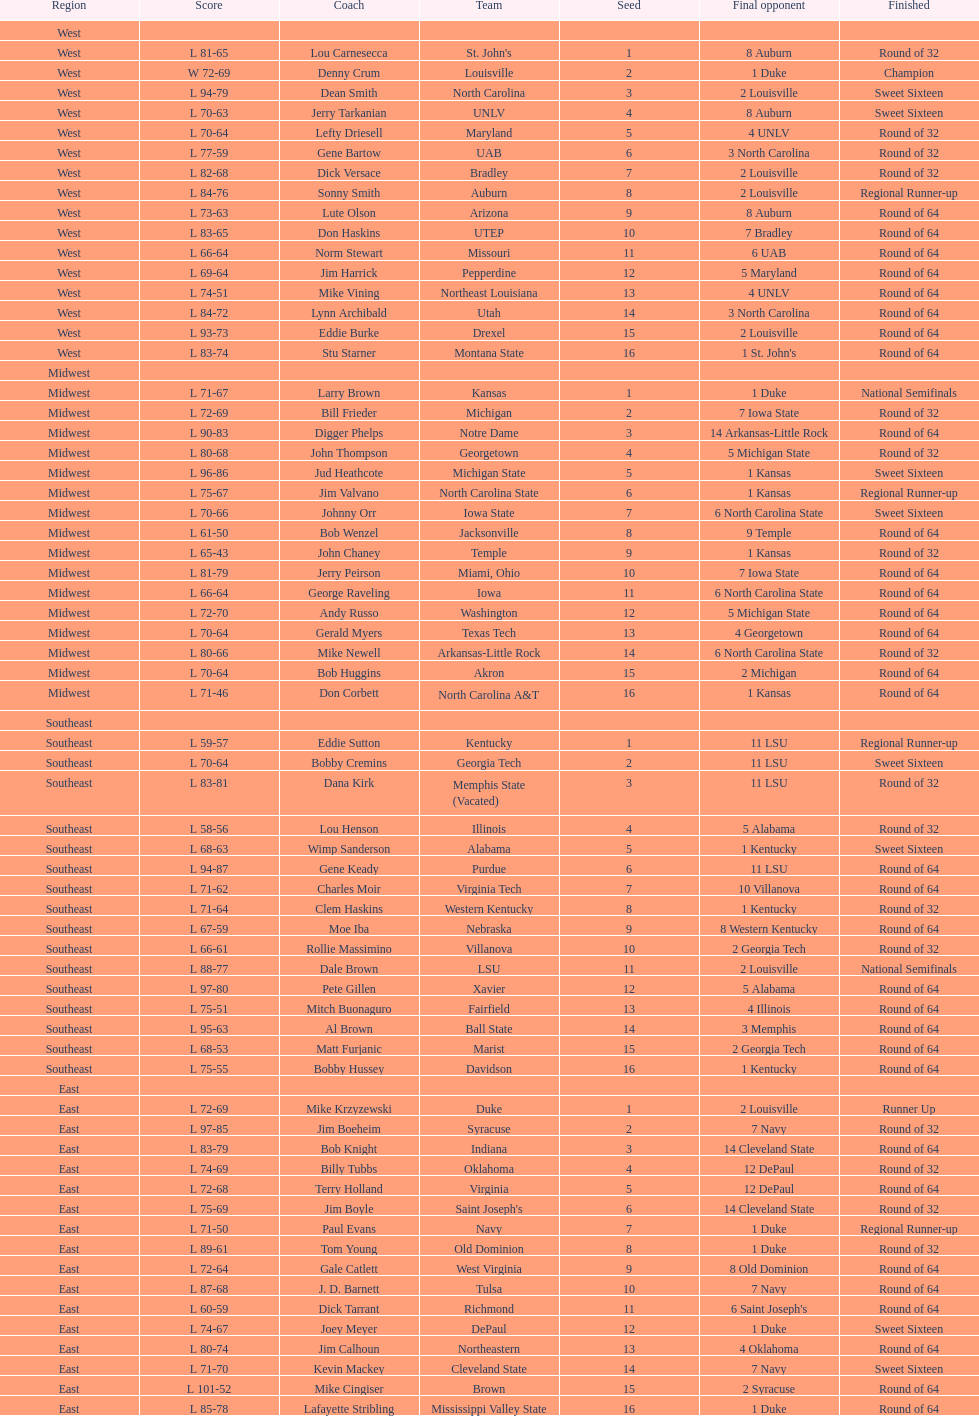Who was the only champion? Louisville. 